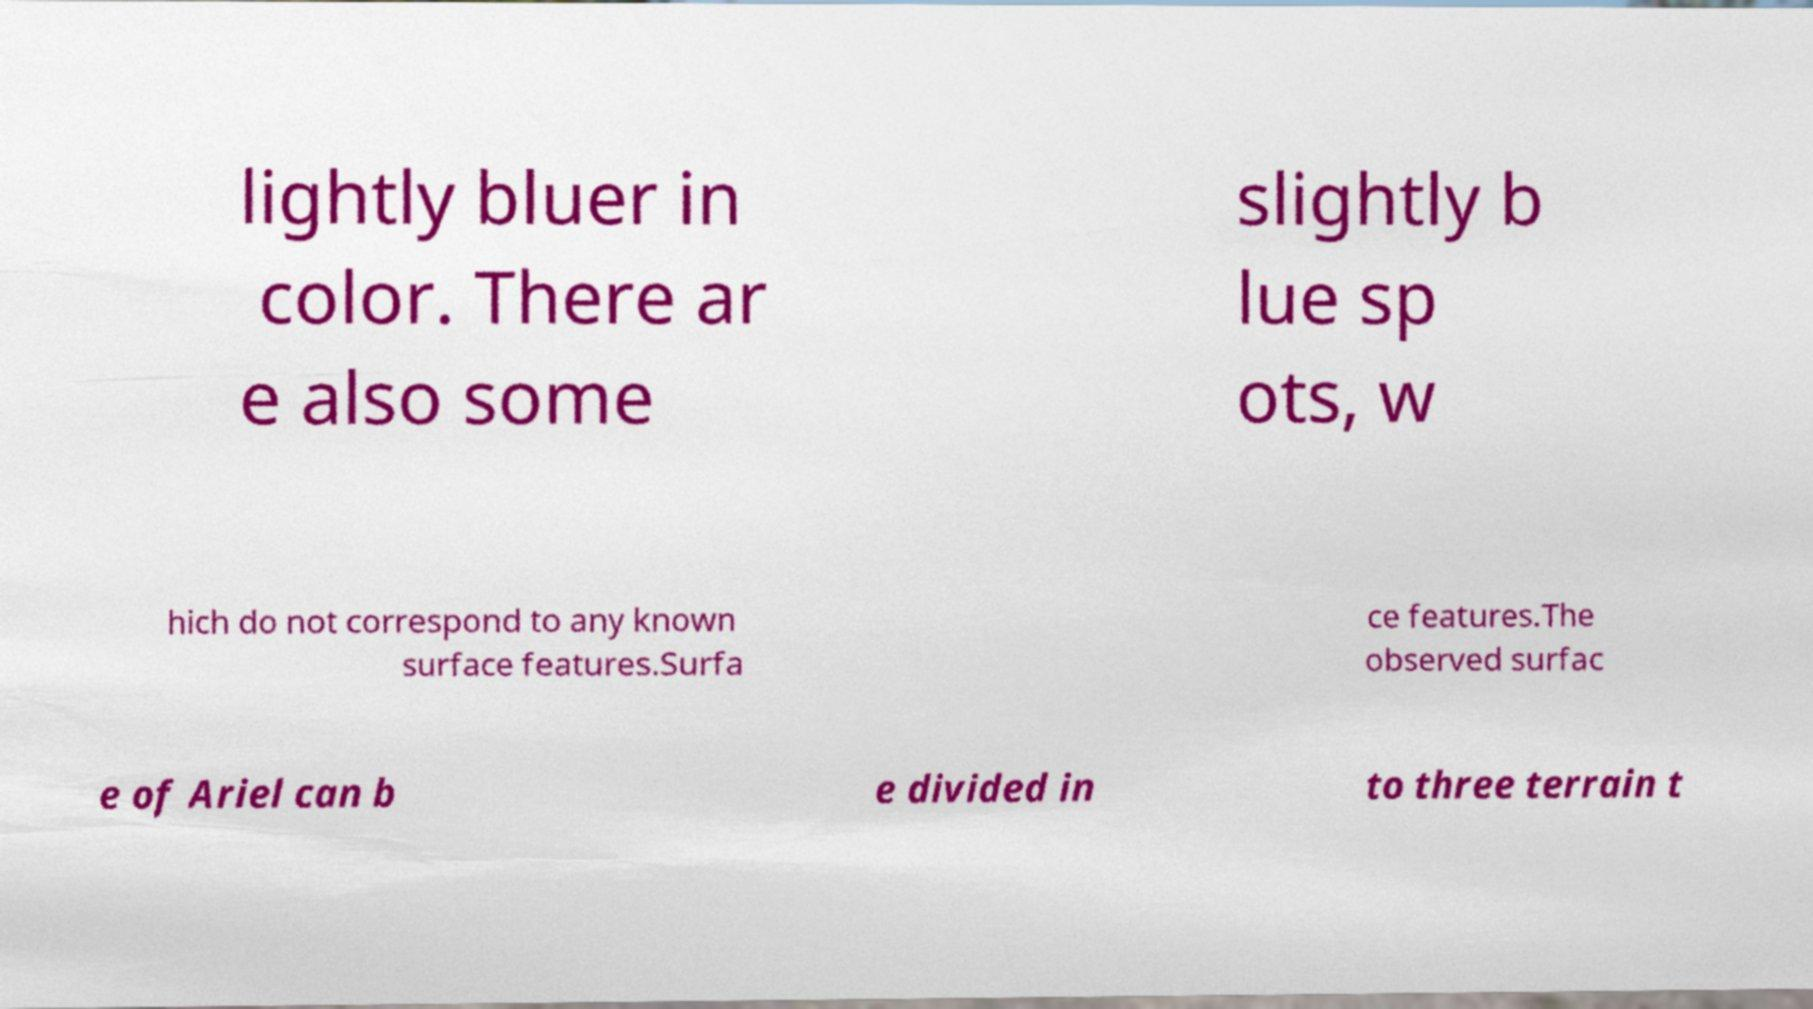There's text embedded in this image that I need extracted. Can you transcribe it verbatim? lightly bluer in color. There ar e also some slightly b lue sp ots, w hich do not correspond to any known surface features.Surfa ce features.The observed surfac e of Ariel can b e divided in to three terrain t 